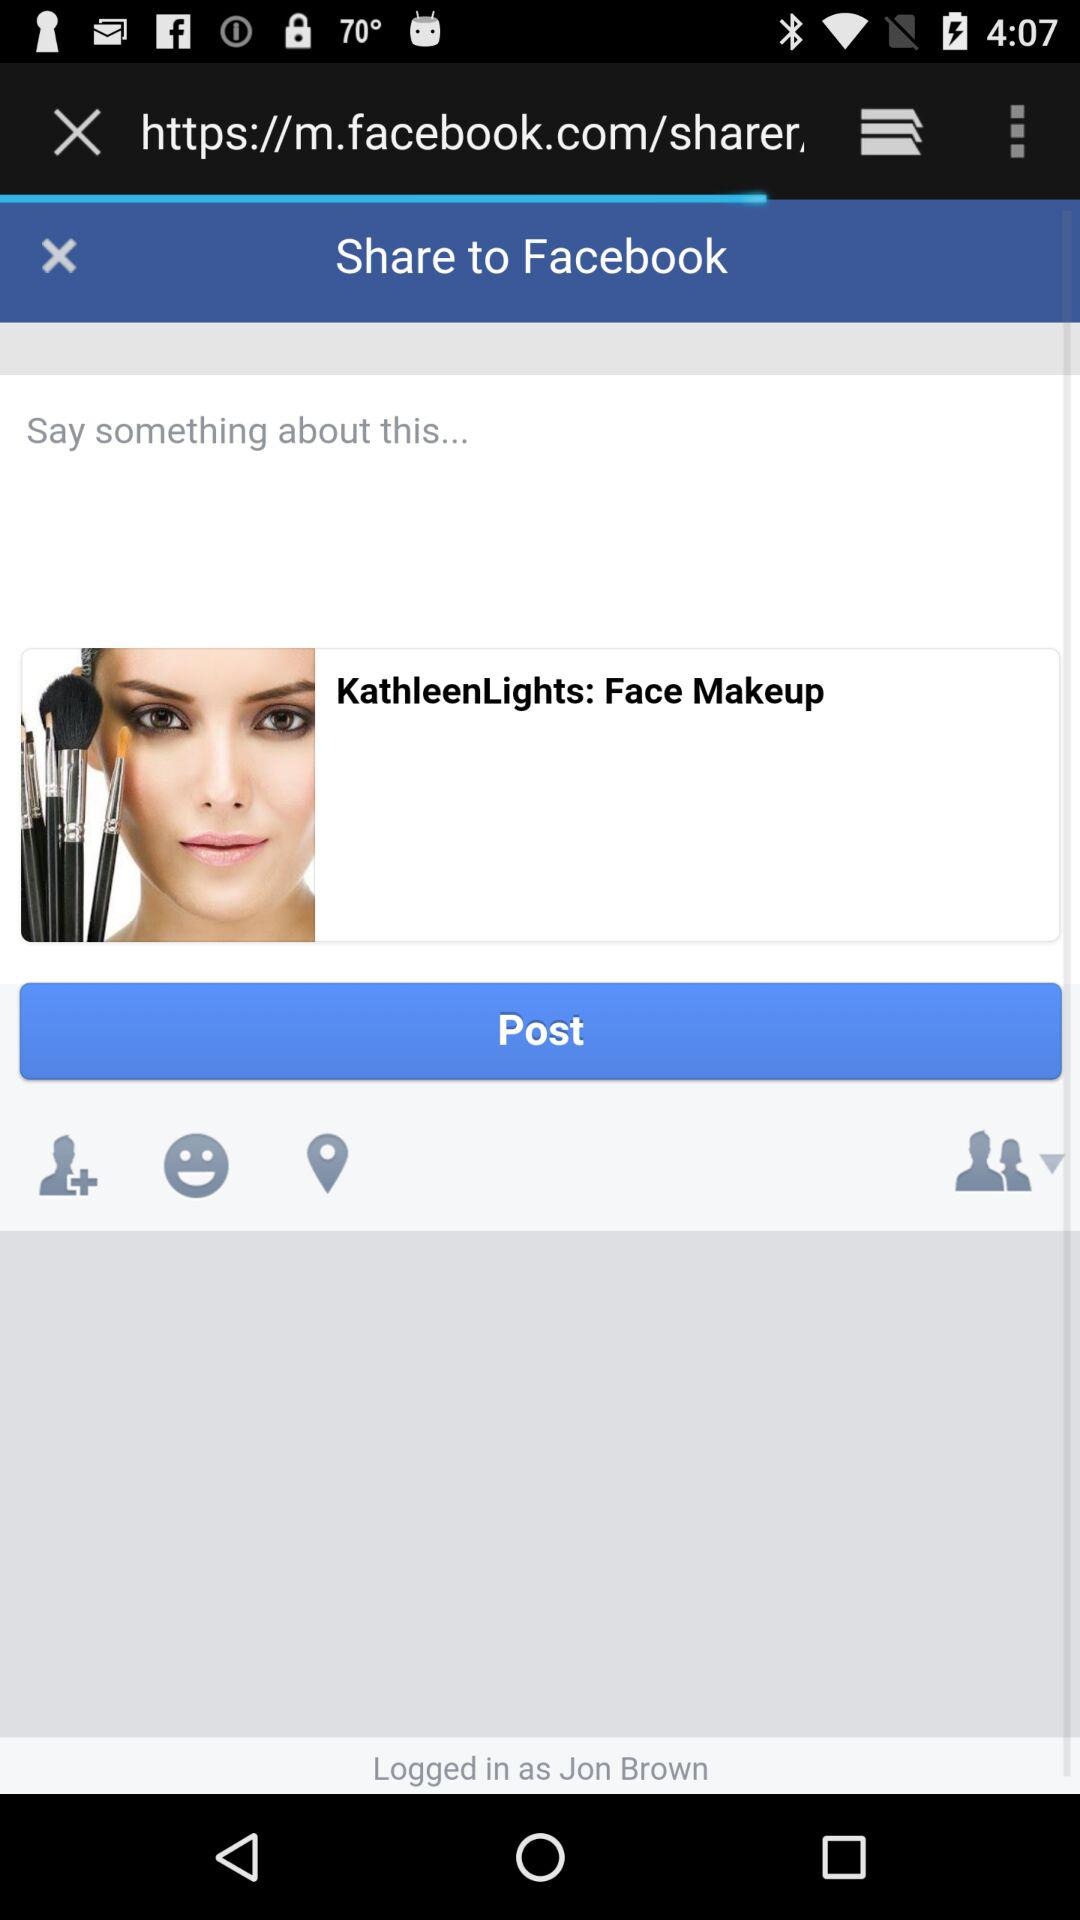How many likes are on the post?
When the provided information is insufficient, respond with <no answer>. <no answer> 